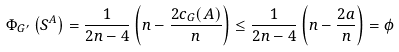Convert formula to latex. <formula><loc_0><loc_0><loc_500><loc_500>\Phi _ { G ^ { \prime } } \left ( S ^ { A } \right ) = \frac { 1 } { 2 n - 4 } \left ( n - \frac { 2 c _ { G } ( A ) } { n } \right ) \leq \frac { 1 } { 2 n - 4 } \left ( n - \frac { 2 a } { n } \right ) = \phi</formula> 